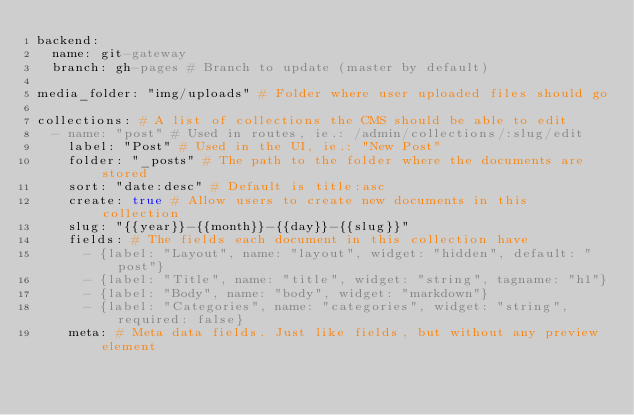Convert code to text. <code><loc_0><loc_0><loc_500><loc_500><_YAML_>backend:
  name: git-gateway
  branch: gh-pages # Branch to update (master by default)

media_folder: "img/uploads" # Folder where user uploaded files should go

collections: # A list of collections the CMS should be able to edit
  - name: "post" # Used in routes, ie.: /admin/collections/:slug/edit
    label: "Post" # Used in the UI, ie.: "New Post"
    folder: "_posts" # The path to the folder where the documents are stored
    sort: "date:desc" # Default is title:asc
    create: true # Allow users to create new documents in this collection
    slug: "{{year}}-{{month}}-{{day}}-{{slug}}"
    fields: # The fields each document in this collection have
      - {label: "Layout", name: "layout", widget: "hidden", default: "post"}
      - {label: "Title", name: "title", widget: "string", tagname: "h1"}
      - {label: "Body", name: "body", widget: "markdown"}
      - {label: "Categories", name: "categories", widget: "string", required: false}
    meta: # Meta data fields. Just like fields, but without any preview element</code> 